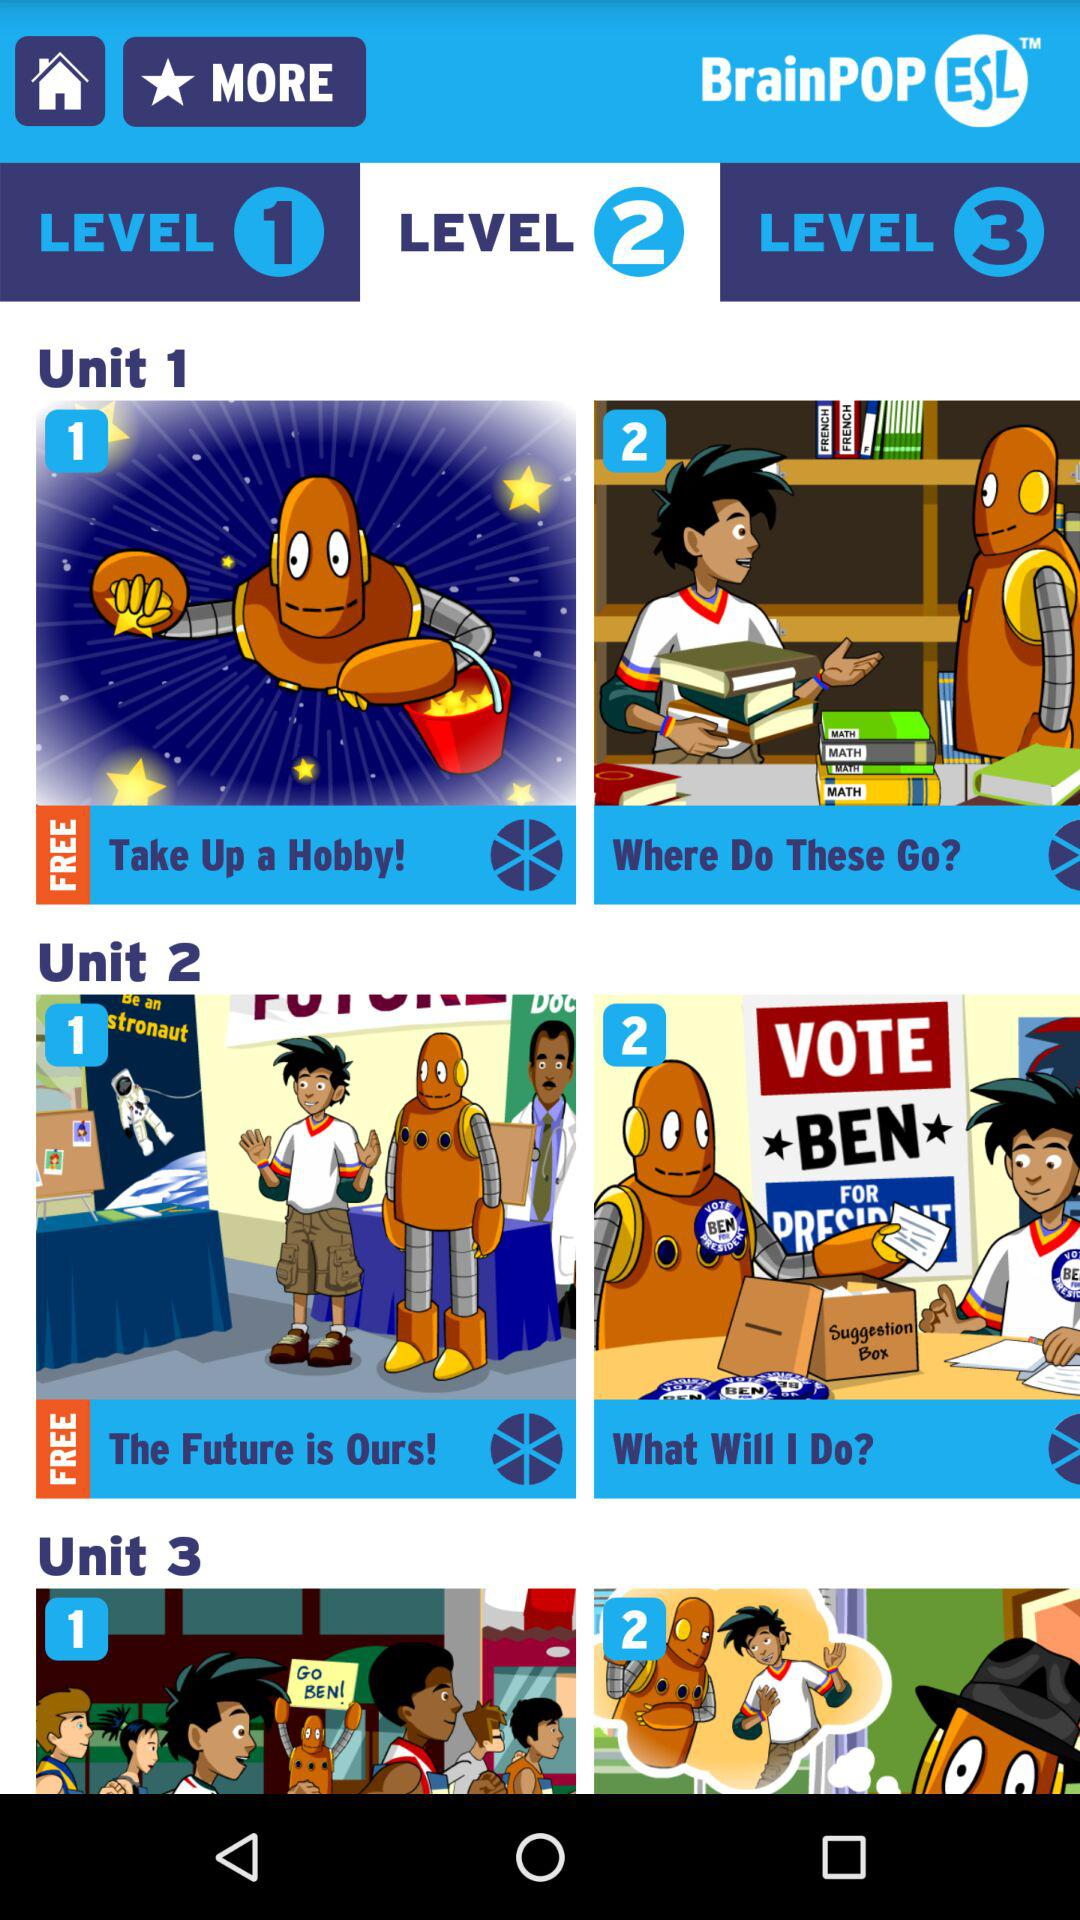How many units are there on the screen?
Answer the question using a single word or phrase. 3 